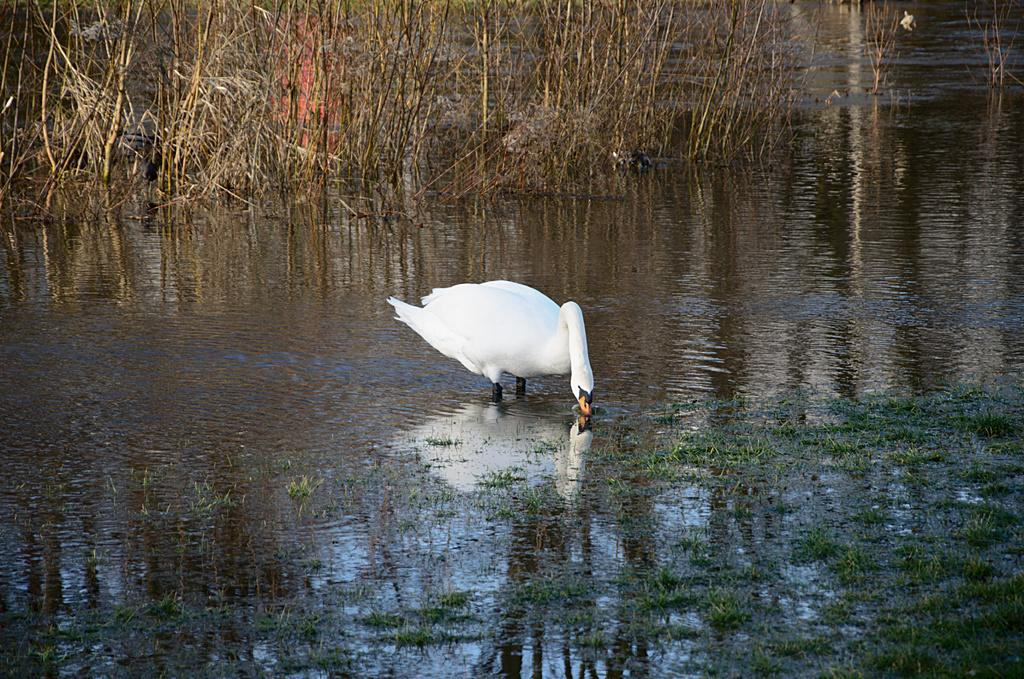What animal can be seen in the water in the image? There is a swan in the water in the image. What type of vegetation is visible in the image? There is grass and plants visible in the image. What else can be seen in the image besides the swan and vegetation? There are objects in the image. What is a unique feature of the swan in the image? The reflection of the swan is visible in the water. How many dimes are scattered on the grass in the image? There are no dimes visible in the image; it features a swan in the water, grass, plants, and objects. What type of creature can be seen climbing the plants in the image? There is no creature climbing the plants in the image; it only features a swan, grass, plants, and objects. 